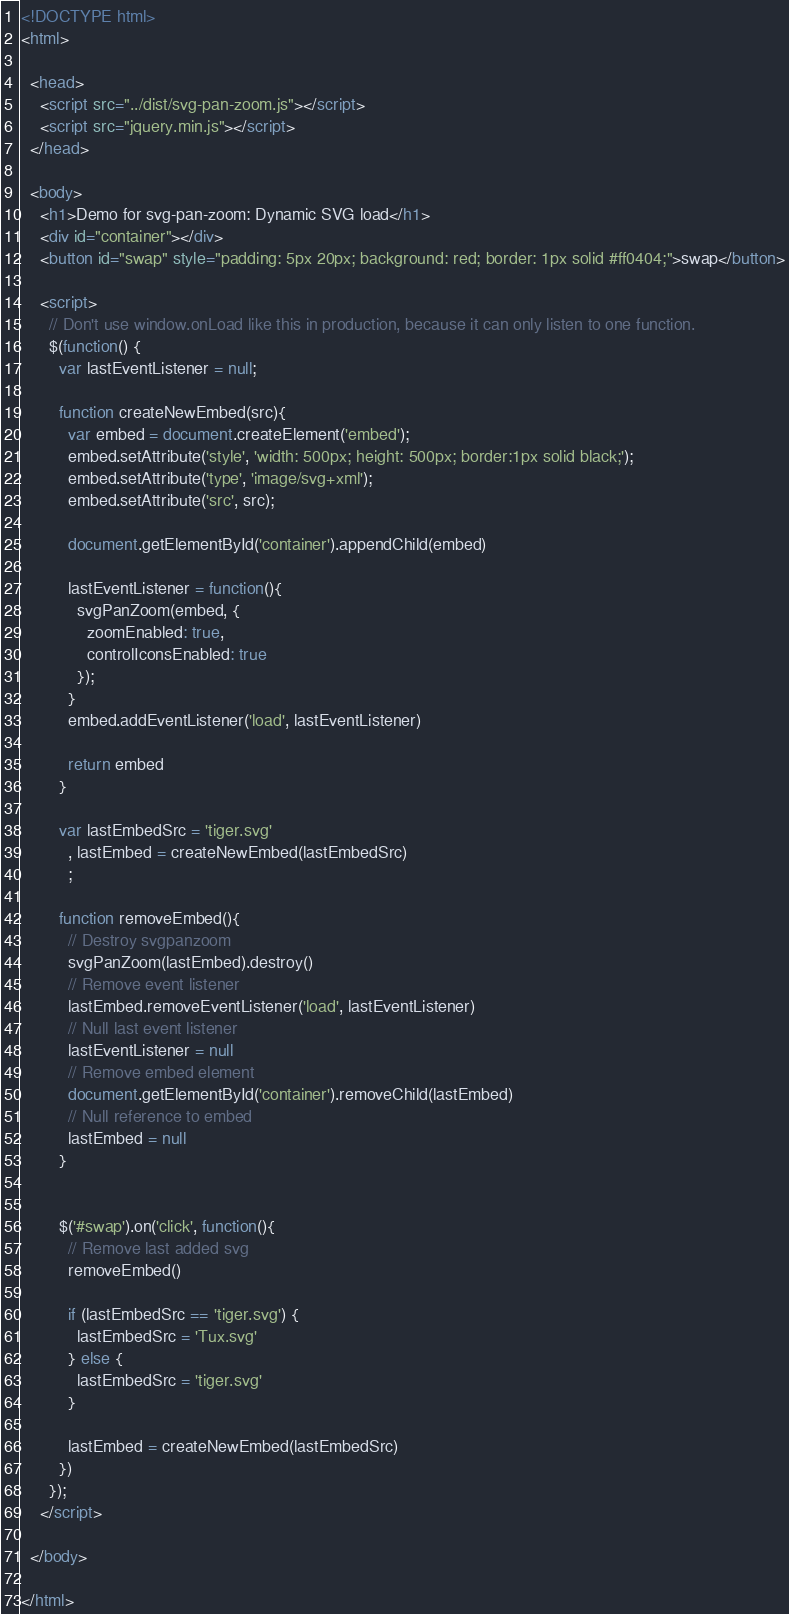Convert code to text. <code><loc_0><loc_0><loc_500><loc_500><_HTML_><!DOCTYPE html>
<html>

  <head>
    <script src="../dist/svg-pan-zoom.js"></script>
    <script src="jquery.min.js"></script>
  </head>

  <body>
    <h1>Demo for svg-pan-zoom: Dynamic SVG load</h1>
    <div id="container"></div>
    <button id="swap" style="padding: 5px 20px; background: red; border: 1px solid #ff0404;">swap</button>

    <script>
      // Don't use window.onLoad like this in production, because it can only listen to one function.
      $(function() {
        var lastEventListener = null;

        function createNewEmbed(src){
          var embed = document.createElement('embed');
          embed.setAttribute('style', 'width: 500px; height: 500px; border:1px solid black;');
          embed.setAttribute('type', 'image/svg+xml');
          embed.setAttribute('src', src);

          document.getElementById('container').appendChild(embed)

          lastEventListener = function(){
            svgPanZoom(embed, {
              zoomEnabled: true,
              controlIconsEnabled: true
            });
          }
          embed.addEventListener('load', lastEventListener)

          return embed
        }

        var lastEmbedSrc = 'tiger.svg'
          , lastEmbed = createNewEmbed(lastEmbedSrc)
          ;

        function removeEmbed(){
          // Destroy svgpanzoom
          svgPanZoom(lastEmbed).destroy()
          // Remove event listener
          lastEmbed.removeEventListener('load', lastEventListener)
          // Null last event listener
          lastEventListener = null
          // Remove embed element
          document.getElementById('container').removeChild(lastEmbed)
          // Null reference to embed
          lastEmbed = null
        }


        $('#swap').on('click', function(){
          // Remove last added svg
          removeEmbed()

          if (lastEmbedSrc == 'tiger.svg') {
            lastEmbedSrc = 'Tux.svg'
          } else {
            lastEmbedSrc = 'tiger.svg'
          }

          lastEmbed = createNewEmbed(lastEmbedSrc)
        })
      });
    </script>

  </body>

</html>
</code> 